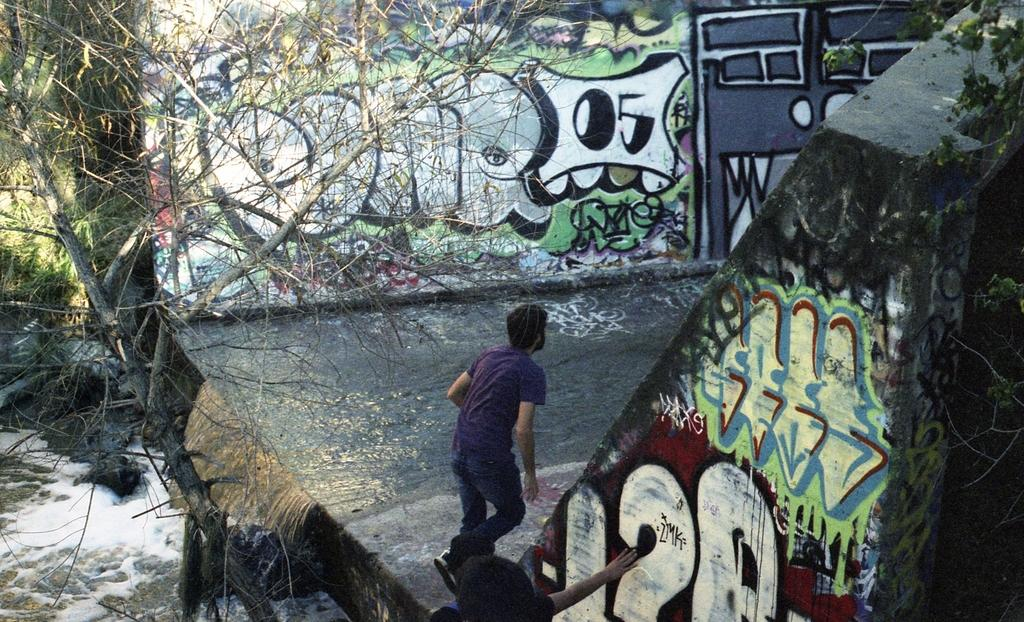What is the person in the image doing? There is a person walking on the road in the image. What is the location of the road in relation to the water? The road is beside the water in the image. What type of vegetation can be seen in the image? There is a tree visible in the image. What type of artwork can be seen on the walls in the image? There is graffiti on the walls in the image. What date is marked on the calendar in the image? There is no calendar present in the image. How does the person in the image wave good-bye to someone? The image does not show the person waving good-bye to anyone. 